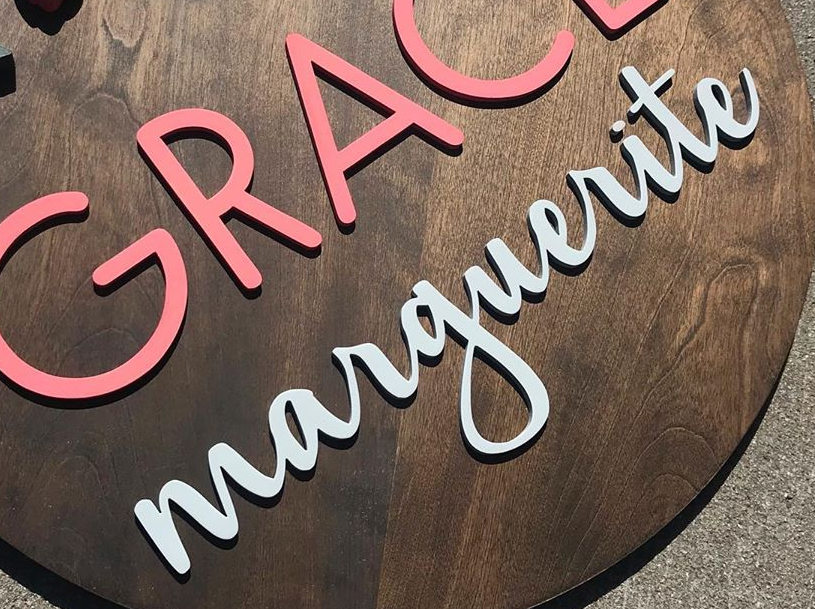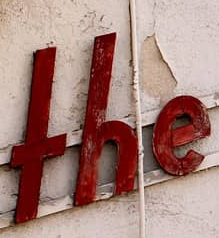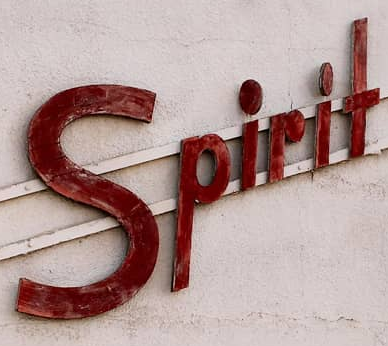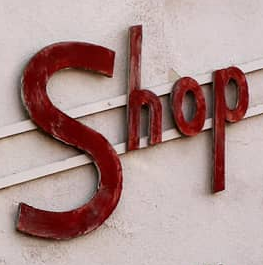Read the text from these images in sequence, separated by a semicolon. marguerite; THE; Spirit; Shop 